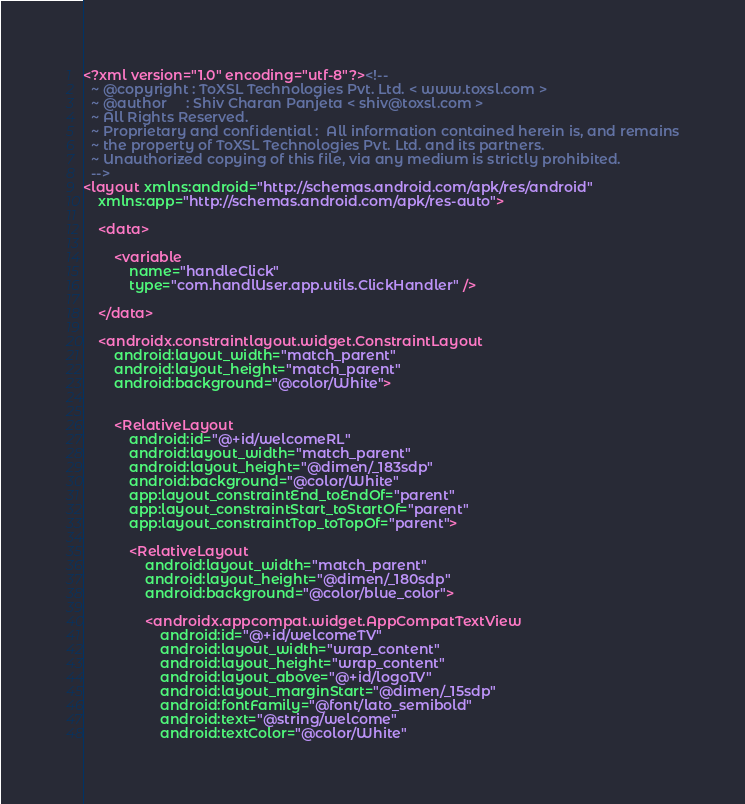<code> <loc_0><loc_0><loc_500><loc_500><_XML_><?xml version="1.0" encoding="utf-8"?><!--
  ~ @copyright : ToXSL Technologies Pvt. Ltd. < www.toxsl.com >
  ~ @author     : Shiv Charan Panjeta < shiv@toxsl.com >
  ~ All Rights Reserved.
  ~ Proprietary and confidential :  All information contained herein is, and remains
  ~ the property of ToXSL Technologies Pvt. Ltd. and its partners.
  ~ Unauthorized copying of this file, via any medium is strictly prohibited.
  -->
<layout xmlns:android="http://schemas.android.com/apk/res/android"
    xmlns:app="http://schemas.android.com/apk/res-auto">

    <data>

        <variable
            name="handleClick"
            type="com.handlUser.app.utils.ClickHandler" />

    </data>

    <androidx.constraintlayout.widget.ConstraintLayout
        android:layout_width="match_parent"
        android:layout_height="match_parent"
        android:background="@color/White">


        <RelativeLayout
            android:id="@+id/welcomeRL"
            android:layout_width="match_parent"
            android:layout_height="@dimen/_183sdp"
            android:background="@color/White"
            app:layout_constraintEnd_toEndOf="parent"
            app:layout_constraintStart_toStartOf="parent"
            app:layout_constraintTop_toTopOf="parent">

            <RelativeLayout
                android:layout_width="match_parent"
                android:layout_height="@dimen/_180sdp"
                android:background="@color/blue_color">

                <androidx.appcompat.widget.AppCompatTextView
                    android:id="@+id/welcomeTV"
                    android:layout_width="wrap_content"
                    android:layout_height="wrap_content"
                    android:layout_above="@+id/logoIV"
                    android:layout_marginStart="@dimen/_15sdp"
                    android:fontFamily="@font/lato_semibold"
                    android:text="@string/welcome"
                    android:textColor="@color/White"</code> 